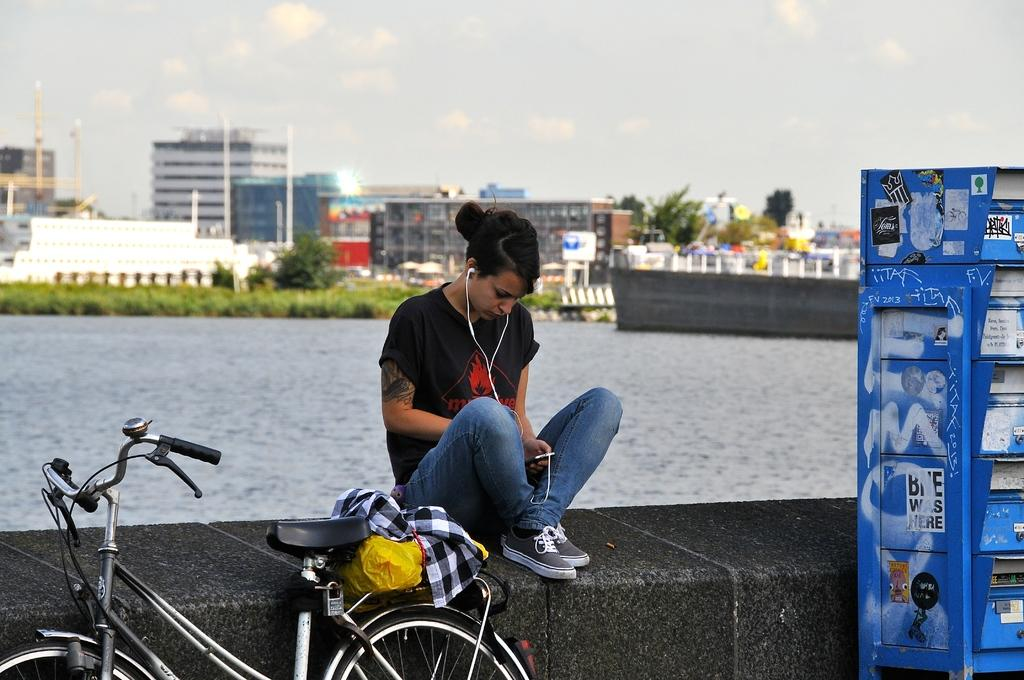What is the main object in the image? There is a bicycle in the image. What is the girl in the image doing? The girl is sitting on a rock in the image. What can be seen in the image besides the bicycle and the girl? There is water in the image. What is visible in the background of the image? The sky is visible in the background of the image. What type of hose is being used to water the plants in the image? There is no hose or plants present in the image. What is the girl's reaction to the development in the image? There is no development or reaction mentioned in the image; it only shows a girl sitting on a rock and a bicycle. 